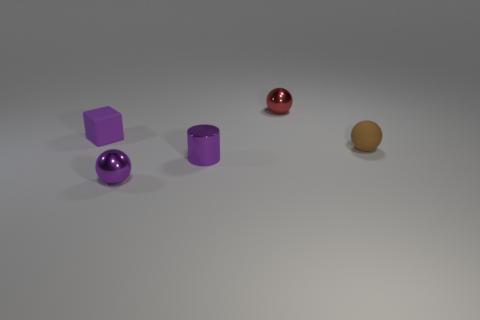What is the shape of the red object that is the same material as the tiny cylinder?
Provide a short and direct response. Sphere. There is a rubber object to the right of the sphere that is behind the small purple rubber cube; what size is it?
Your answer should be compact. Small. What color is the tiny sphere that is in front of the brown ball?
Offer a very short reply. Purple. Is there another thing that has the same shape as the small red metallic thing?
Offer a terse response. Yes. Is the number of purple things in front of the small red metallic object less than the number of balls that are to the right of the tiny brown matte sphere?
Offer a very short reply. No. The rubber sphere has what color?
Your answer should be compact. Brown. There is a tiny shiny sphere that is in front of the tiny block; is there a thing in front of it?
Offer a very short reply. No. How many red metal things are the same size as the rubber cube?
Your answer should be very brief. 1. How many small objects are on the left side of the small metallic thing behind the tiny rubber thing that is right of the tiny purple rubber block?
Make the answer very short. 3. What number of shiny balls are both in front of the tiny rubber ball and behind the purple cylinder?
Provide a short and direct response. 0. 